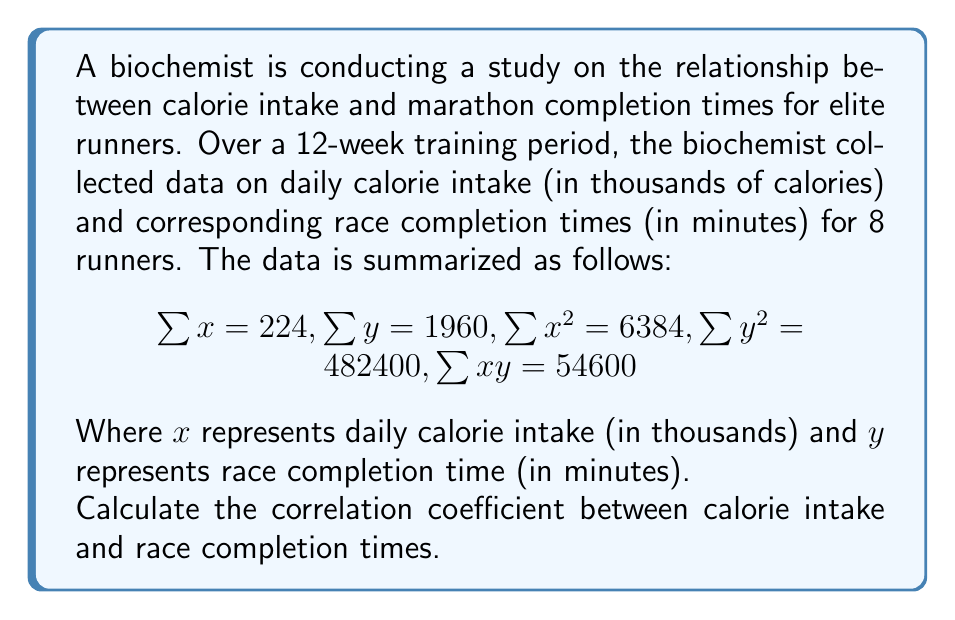Give your solution to this math problem. To calculate the correlation coefficient, we'll use the formula:

$$r = \frac{n\sum xy - \sum x \sum y}{\sqrt{[n\sum x^2 - (\sum x)^2][n\sum y^2 - (\sum y)^2]}}$$

Where $n$ is the number of data points, which is 8 in this case.

Let's substitute the given values:

$$r = \frac{8(54600) - (224)(1960)}{\sqrt{[8(6384) - (224)^2][8(482400) - (1960)^2]}}$$

Now, let's calculate step by step:

1) Numerator:
   $8(54600) - (224)(1960) = 436800 - 439040 = -2240$

2) Denominator:
   $[8(6384) - (224)^2] = 51072 - 50176 = 896$
   $[8(482400) - (1960)^2] = 3859200 - 3841600 = 17600$
   
   $\sqrt{896 * 17600} = \sqrt{15769600} = 3970.59$

3) Putting it all together:

$$r = \frac{-2240}{3970.59} = -0.5641$$

The correlation coefficient is approximately -0.5641.
Answer: $r \approx -0.5641$ 